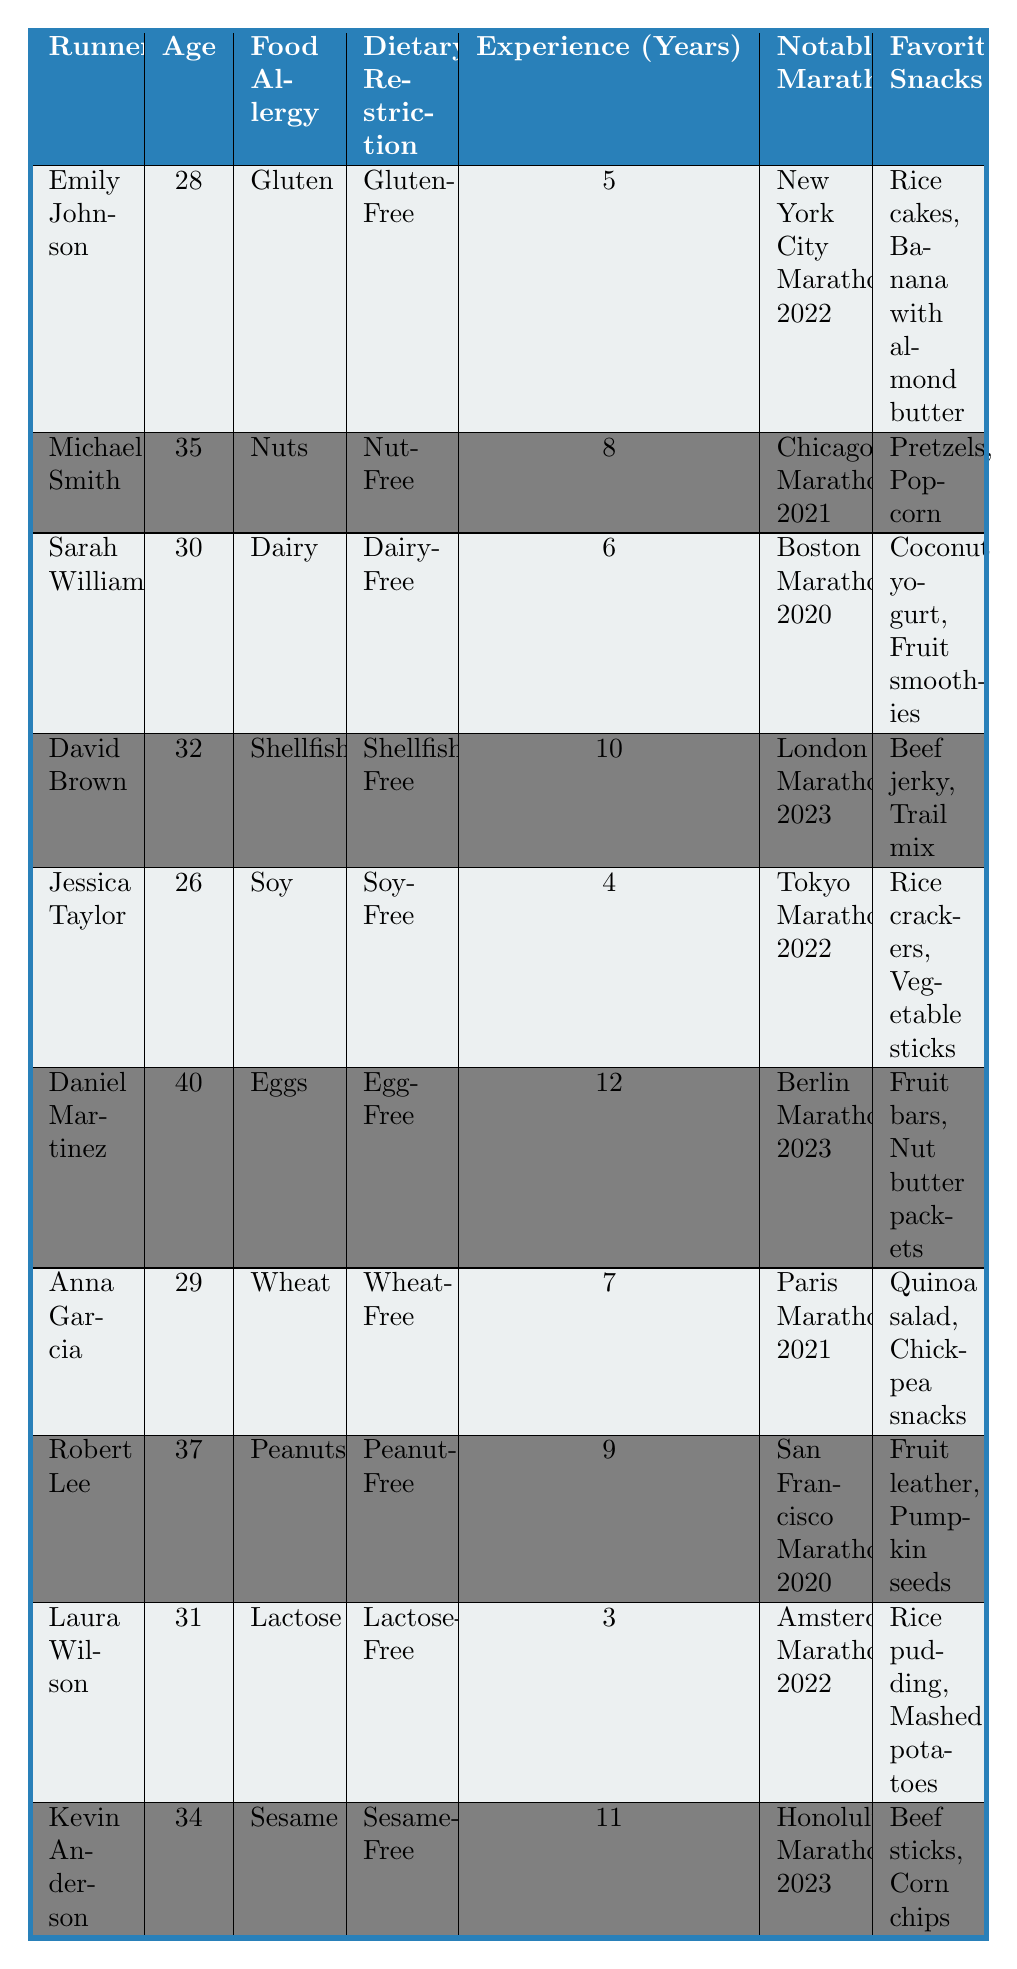What is Emily Johnson's notable marathon? According to the table, Emily Johnson's notable marathon is the New York City Marathon 2022.
Answer: New York City Marathon 2022 How many years of running experience does Daniel Martinez have? The table states that Daniel Martinez has 12 years of running experience.
Answer: 12 Is Laura Wilson dairy-free? The table indicates that Laura Wilson has a dairy allergy and follows a dairy-free diet; therefore, the answer is yes.
Answer: Yes Which runner has the longest running experience, and how many years do they have? By examining the running experience column, David Brown has 10 years, but Daniel Martinez has 12 years, making him the runner with the most experience.
Answer: Daniel Martinez, 12 years How many runners listed have a gluten allergy? The table shows that only Emily Johnson has a gluten allergy, indicating there is one runner with this allergy.
Answer: 1 What are the favorite snacks of Anna Garcia? Looking at the listed favorite snacks for Anna Garcia in the table, they are quinoa salad and chickpea snacks.
Answer: Quinoa salad, chickpea snacks Does any runner in the table have a shellfish allergy? The table confirms that David Brown has a shellfish allergy, thus the answer is yes.
Answer: Yes What is the age difference between the youngest and oldest runners in the table? The youngest runner, Jessica Taylor, is 26, and the oldest, Daniel Martinez, is 40. The age difference is calculated as 40 - 26 = 14.
Answer: 14 Which runner has the peanut allergy and what are their favorite snacks? By checking the table, Robert Lee has a peanut allergy, and his favorite snacks are fruit leather and pumpkin seeds.
Answer: Robert Lee; fruit leather, pumpkin seeds How many runners have dietary restrictions that involve being free of both eggs and nuts? The table highlights that Daniel Martinez is egg-free and Michael Smith is nut-free. However, they are two separate individuals with different restrictions. Therefore, there are two runners: one egg-free and another nut-free but not both in the same person.
Answer: 2 Is there a runner who has both a dairy allergy and an age under 30? From the table, Sarah Williams has a dairy allergy but her age is 30, while Anna Garcia is 29 and does not have a dairy allergy, so no runner fits this description.
Answer: No 